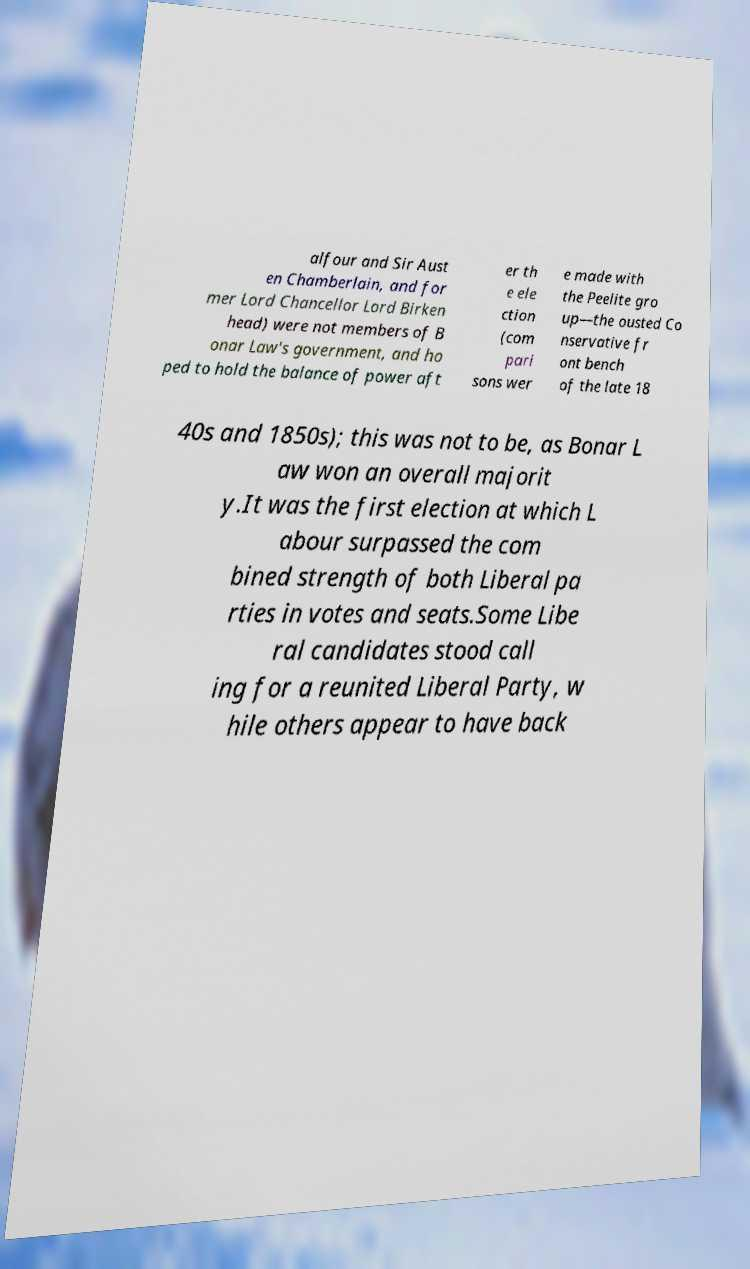For documentation purposes, I need the text within this image transcribed. Could you provide that? alfour and Sir Aust en Chamberlain, and for mer Lord Chancellor Lord Birken head) were not members of B onar Law's government, and ho ped to hold the balance of power aft er th e ele ction (com pari sons wer e made with the Peelite gro up—the ousted Co nservative fr ont bench of the late 18 40s and 1850s); this was not to be, as Bonar L aw won an overall majorit y.It was the first election at which L abour surpassed the com bined strength of both Liberal pa rties in votes and seats.Some Libe ral candidates stood call ing for a reunited Liberal Party, w hile others appear to have back 